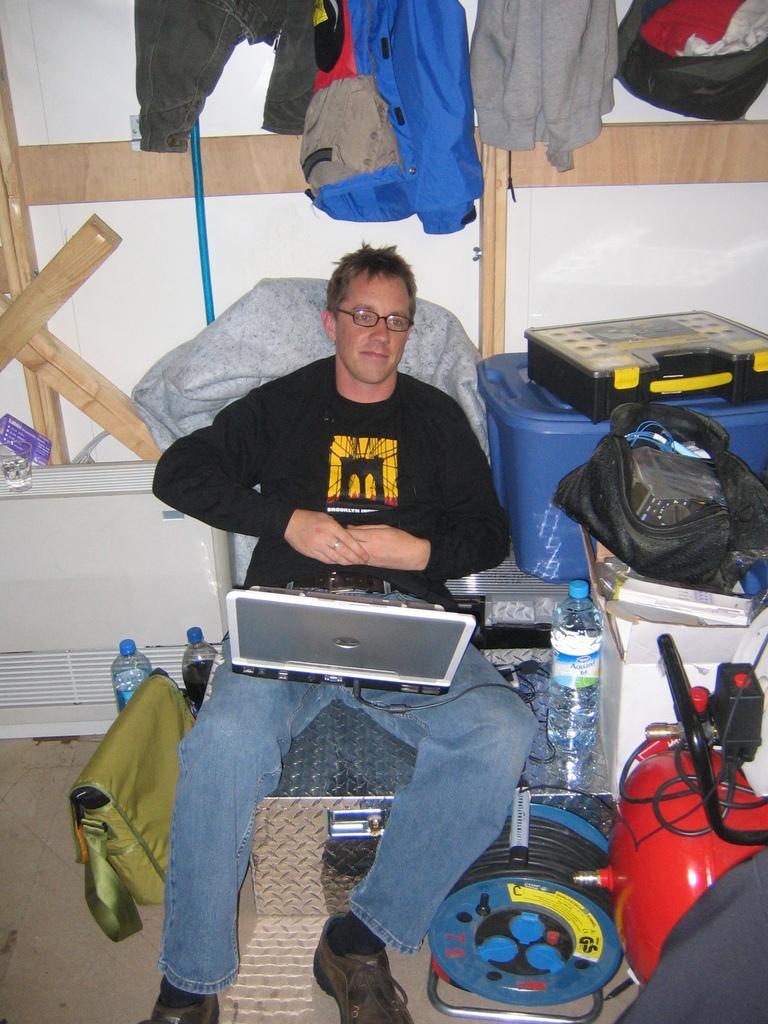How would you summarize this image in a sentence or two? In this picture I can see a man sitting, there are clothes, water bottles and some other objects. 